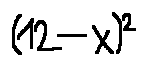Convert formula to latex. <formula><loc_0><loc_0><loc_500><loc_500>( 1 2 - x ) ^ { 2 }</formula> 